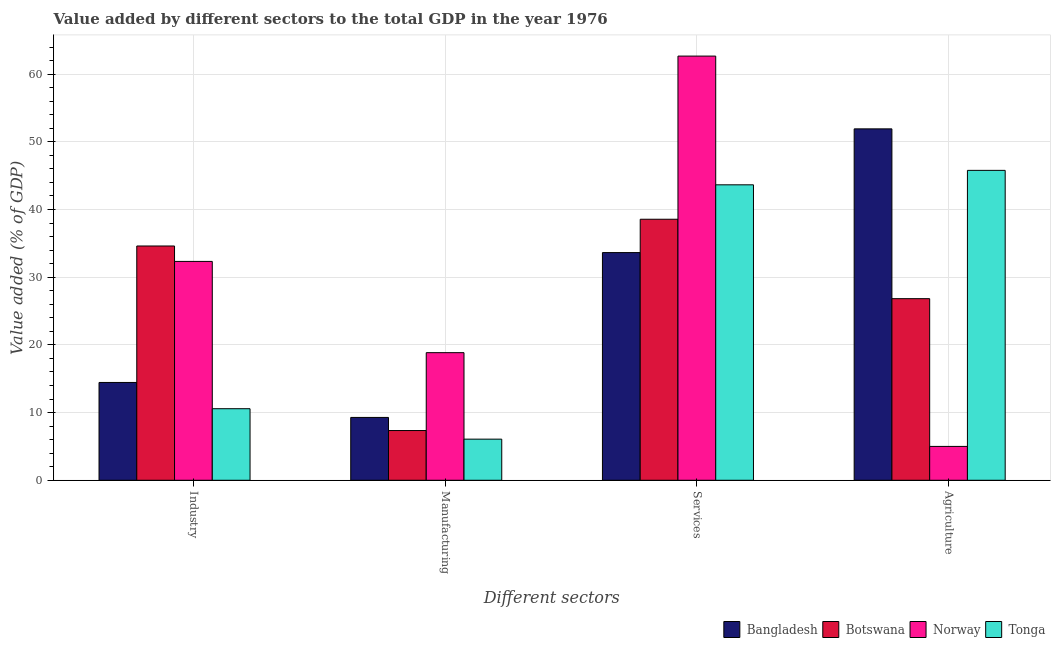How many groups of bars are there?
Your answer should be compact. 4. Are the number of bars per tick equal to the number of legend labels?
Keep it short and to the point. Yes. Are the number of bars on each tick of the X-axis equal?
Offer a very short reply. Yes. How many bars are there on the 3rd tick from the left?
Keep it short and to the point. 4. How many bars are there on the 3rd tick from the right?
Make the answer very short. 4. What is the label of the 3rd group of bars from the left?
Keep it short and to the point. Services. What is the value added by industrial sector in Bangladesh?
Give a very brief answer. 14.45. Across all countries, what is the maximum value added by manufacturing sector?
Offer a terse response. 18.85. Across all countries, what is the minimum value added by manufacturing sector?
Give a very brief answer. 6.07. What is the total value added by manufacturing sector in the graph?
Offer a terse response. 41.56. What is the difference between the value added by services sector in Bangladesh and that in Botswana?
Give a very brief answer. -4.92. What is the difference between the value added by services sector in Bangladesh and the value added by manufacturing sector in Botswana?
Offer a very short reply. 26.29. What is the average value added by services sector per country?
Keep it short and to the point. 44.63. What is the difference between the value added by agricultural sector and value added by industrial sector in Botswana?
Your answer should be compact. -7.78. In how many countries, is the value added by manufacturing sector greater than 6 %?
Offer a terse response. 4. What is the ratio of the value added by industrial sector in Bangladesh to that in Botswana?
Give a very brief answer. 0.42. Is the value added by agricultural sector in Norway less than that in Botswana?
Offer a terse response. Yes. What is the difference between the highest and the second highest value added by services sector?
Offer a terse response. 19.02. What is the difference between the highest and the lowest value added by agricultural sector?
Your response must be concise. 46.91. In how many countries, is the value added by agricultural sector greater than the average value added by agricultural sector taken over all countries?
Provide a succinct answer. 2. What does the 1st bar from the left in Manufacturing represents?
Make the answer very short. Bangladesh. What does the 3rd bar from the right in Agriculture represents?
Offer a terse response. Botswana. Is it the case that in every country, the sum of the value added by industrial sector and value added by manufacturing sector is greater than the value added by services sector?
Ensure brevity in your answer.  No. How many bars are there?
Your answer should be compact. 16. How many countries are there in the graph?
Provide a short and direct response. 4. What is the difference between two consecutive major ticks on the Y-axis?
Your answer should be very brief. 10. Are the values on the major ticks of Y-axis written in scientific E-notation?
Offer a terse response. No. Does the graph contain any zero values?
Offer a very short reply. No. Where does the legend appear in the graph?
Offer a terse response. Bottom right. How many legend labels are there?
Give a very brief answer. 4. What is the title of the graph?
Keep it short and to the point. Value added by different sectors to the total GDP in the year 1976. Does "Netherlands" appear as one of the legend labels in the graph?
Keep it short and to the point. No. What is the label or title of the X-axis?
Offer a very short reply. Different sectors. What is the label or title of the Y-axis?
Offer a very short reply. Value added (% of GDP). What is the Value added (% of GDP) of Bangladesh in Industry?
Your answer should be very brief. 14.45. What is the Value added (% of GDP) in Botswana in Industry?
Offer a terse response. 34.61. What is the Value added (% of GDP) of Norway in Industry?
Make the answer very short. 32.33. What is the Value added (% of GDP) of Tonga in Industry?
Offer a terse response. 10.57. What is the Value added (% of GDP) of Bangladesh in Manufacturing?
Keep it short and to the point. 9.28. What is the Value added (% of GDP) of Botswana in Manufacturing?
Provide a succinct answer. 7.35. What is the Value added (% of GDP) in Norway in Manufacturing?
Offer a terse response. 18.85. What is the Value added (% of GDP) in Tonga in Manufacturing?
Provide a short and direct response. 6.07. What is the Value added (% of GDP) in Bangladesh in Services?
Offer a terse response. 33.64. What is the Value added (% of GDP) of Botswana in Services?
Your answer should be very brief. 38.56. What is the Value added (% of GDP) of Norway in Services?
Give a very brief answer. 62.67. What is the Value added (% of GDP) of Tonga in Services?
Give a very brief answer. 43.65. What is the Value added (% of GDP) of Bangladesh in Agriculture?
Offer a very short reply. 51.91. What is the Value added (% of GDP) of Botswana in Agriculture?
Provide a short and direct response. 26.83. What is the Value added (% of GDP) of Norway in Agriculture?
Provide a short and direct response. 5. What is the Value added (% of GDP) in Tonga in Agriculture?
Give a very brief answer. 45.78. Across all Different sectors, what is the maximum Value added (% of GDP) in Bangladesh?
Your answer should be compact. 51.91. Across all Different sectors, what is the maximum Value added (% of GDP) of Botswana?
Offer a terse response. 38.56. Across all Different sectors, what is the maximum Value added (% of GDP) of Norway?
Your response must be concise. 62.67. Across all Different sectors, what is the maximum Value added (% of GDP) of Tonga?
Provide a short and direct response. 45.78. Across all Different sectors, what is the minimum Value added (% of GDP) of Bangladesh?
Provide a succinct answer. 9.28. Across all Different sectors, what is the minimum Value added (% of GDP) of Botswana?
Offer a very short reply. 7.35. Across all Different sectors, what is the minimum Value added (% of GDP) of Norway?
Keep it short and to the point. 5. Across all Different sectors, what is the minimum Value added (% of GDP) in Tonga?
Make the answer very short. 6.07. What is the total Value added (% of GDP) in Bangladesh in the graph?
Your response must be concise. 109.28. What is the total Value added (% of GDP) in Botswana in the graph?
Offer a very short reply. 107.35. What is the total Value added (% of GDP) in Norway in the graph?
Your answer should be compact. 118.85. What is the total Value added (% of GDP) of Tonga in the graph?
Keep it short and to the point. 106.07. What is the difference between the Value added (% of GDP) of Bangladesh in Industry and that in Manufacturing?
Provide a succinct answer. 5.17. What is the difference between the Value added (% of GDP) in Botswana in Industry and that in Manufacturing?
Your response must be concise. 27.27. What is the difference between the Value added (% of GDP) in Norway in Industry and that in Manufacturing?
Provide a short and direct response. 13.48. What is the difference between the Value added (% of GDP) of Tonga in Industry and that in Manufacturing?
Make the answer very short. 4.5. What is the difference between the Value added (% of GDP) in Bangladesh in Industry and that in Services?
Your answer should be very brief. -19.19. What is the difference between the Value added (% of GDP) in Botswana in Industry and that in Services?
Your answer should be compact. -3.95. What is the difference between the Value added (% of GDP) in Norway in Industry and that in Services?
Offer a very short reply. -30.33. What is the difference between the Value added (% of GDP) of Tonga in Industry and that in Services?
Offer a terse response. -33.08. What is the difference between the Value added (% of GDP) of Bangladesh in Industry and that in Agriculture?
Your response must be concise. -37.47. What is the difference between the Value added (% of GDP) of Botswana in Industry and that in Agriculture?
Provide a succinct answer. 7.78. What is the difference between the Value added (% of GDP) in Norway in Industry and that in Agriculture?
Ensure brevity in your answer.  27.33. What is the difference between the Value added (% of GDP) in Tonga in Industry and that in Agriculture?
Provide a short and direct response. -35.21. What is the difference between the Value added (% of GDP) of Bangladesh in Manufacturing and that in Services?
Your response must be concise. -24.35. What is the difference between the Value added (% of GDP) in Botswana in Manufacturing and that in Services?
Offer a terse response. -31.22. What is the difference between the Value added (% of GDP) in Norway in Manufacturing and that in Services?
Provide a succinct answer. -43.81. What is the difference between the Value added (% of GDP) in Tonga in Manufacturing and that in Services?
Your response must be concise. -37.57. What is the difference between the Value added (% of GDP) of Bangladesh in Manufacturing and that in Agriculture?
Your answer should be very brief. -42.63. What is the difference between the Value added (% of GDP) in Botswana in Manufacturing and that in Agriculture?
Give a very brief answer. -19.48. What is the difference between the Value added (% of GDP) of Norway in Manufacturing and that in Agriculture?
Your answer should be very brief. 13.85. What is the difference between the Value added (% of GDP) in Tonga in Manufacturing and that in Agriculture?
Ensure brevity in your answer.  -39.71. What is the difference between the Value added (% of GDP) of Bangladesh in Services and that in Agriculture?
Make the answer very short. -18.28. What is the difference between the Value added (% of GDP) of Botswana in Services and that in Agriculture?
Ensure brevity in your answer.  11.73. What is the difference between the Value added (% of GDP) in Norway in Services and that in Agriculture?
Provide a short and direct response. 57.66. What is the difference between the Value added (% of GDP) in Tonga in Services and that in Agriculture?
Keep it short and to the point. -2.14. What is the difference between the Value added (% of GDP) of Bangladesh in Industry and the Value added (% of GDP) of Botswana in Manufacturing?
Give a very brief answer. 7.1. What is the difference between the Value added (% of GDP) of Bangladesh in Industry and the Value added (% of GDP) of Norway in Manufacturing?
Your response must be concise. -4.4. What is the difference between the Value added (% of GDP) of Bangladesh in Industry and the Value added (% of GDP) of Tonga in Manufacturing?
Your answer should be compact. 8.37. What is the difference between the Value added (% of GDP) in Botswana in Industry and the Value added (% of GDP) in Norway in Manufacturing?
Your response must be concise. 15.76. What is the difference between the Value added (% of GDP) of Botswana in Industry and the Value added (% of GDP) of Tonga in Manufacturing?
Ensure brevity in your answer.  28.54. What is the difference between the Value added (% of GDP) in Norway in Industry and the Value added (% of GDP) in Tonga in Manufacturing?
Keep it short and to the point. 26.26. What is the difference between the Value added (% of GDP) of Bangladesh in Industry and the Value added (% of GDP) of Botswana in Services?
Your answer should be very brief. -24.11. What is the difference between the Value added (% of GDP) of Bangladesh in Industry and the Value added (% of GDP) of Norway in Services?
Make the answer very short. -48.22. What is the difference between the Value added (% of GDP) of Bangladesh in Industry and the Value added (% of GDP) of Tonga in Services?
Keep it short and to the point. -29.2. What is the difference between the Value added (% of GDP) in Botswana in Industry and the Value added (% of GDP) in Norway in Services?
Keep it short and to the point. -28.05. What is the difference between the Value added (% of GDP) in Botswana in Industry and the Value added (% of GDP) in Tonga in Services?
Your answer should be compact. -9.04. What is the difference between the Value added (% of GDP) in Norway in Industry and the Value added (% of GDP) in Tonga in Services?
Make the answer very short. -11.31. What is the difference between the Value added (% of GDP) in Bangladesh in Industry and the Value added (% of GDP) in Botswana in Agriculture?
Your answer should be compact. -12.38. What is the difference between the Value added (% of GDP) in Bangladesh in Industry and the Value added (% of GDP) in Norway in Agriculture?
Ensure brevity in your answer.  9.45. What is the difference between the Value added (% of GDP) in Bangladesh in Industry and the Value added (% of GDP) in Tonga in Agriculture?
Offer a very short reply. -31.33. What is the difference between the Value added (% of GDP) in Botswana in Industry and the Value added (% of GDP) in Norway in Agriculture?
Make the answer very short. 29.61. What is the difference between the Value added (% of GDP) of Botswana in Industry and the Value added (% of GDP) of Tonga in Agriculture?
Make the answer very short. -11.17. What is the difference between the Value added (% of GDP) of Norway in Industry and the Value added (% of GDP) of Tonga in Agriculture?
Your answer should be very brief. -13.45. What is the difference between the Value added (% of GDP) of Bangladesh in Manufacturing and the Value added (% of GDP) of Botswana in Services?
Offer a terse response. -29.28. What is the difference between the Value added (% of GDP) of Bangladesh in Manufacturing and the Value added (% of GDP) of Norway in Services?
Give a very brief answer. -53.38. What is the difference between the Value added (% of GDP) of Bangladesh in Manufacturing and the Value added (% of GDP) of Tonga in Services?
Offer a terse response. -34.36. What is the difference between the Value added (% of GDP) of Botswana in Manufacturing and the Value added (% of GDP) of Norway in Services?
Your answer should be compact. -55.32. What is the difference between the Value added (% of GDP) in Botswana in Manufacturing and the Value added (% of GDP) in Tonga in Services?
Offer a very short reply. -36.3. What is the difference between the Value added (% of GDP) in Norway in Manufacturing and the Value added (% of GDP) in Tonga in Services?
Your response must be concise. -24.8. What is the difference between the Value added (% of GDP) in Bangladesh in Manufacturing and the Value added (% of GDP) in Botswana in Agriculture?
Your answer should be very brief. -17.54. What is the difference between the Value added (% of GDP) of Bangladesh in Manufacturing and the Value added (% of GDP) of Norway in Agriculture?
Provide a short and direct response. 4.28. What is the difference between the Value added (% of GDP) in Bangladesh in Manufacturing and the Value added (% of GDP) in Tonga in Agriculture?
Your answer should be very brief. -36.5. What is the difference between the Value added (% of GDP) in Botswana in Manufacturing and the Value added (% of GDP) in Norway in Agriculture?
Ensure brevity in your answer.  2.34. What is the difference between the Value added (% of GDP) of Botswana in Manufacturing and the Value added (% of GDP) of Tonga in Agriculture?
Offer a terse response. -38.44. What is the difference between the Value added (% of GDP) of Norway in Manufacturing and the Value added (% of GDP) of Tonga in Agriculture?
Make the answer very short. -26.93. What is the difference between the Value added (% of GDP) in Bangladesh in Services and the Value added (% of GDP) in Botswana in Agriculture?
Your answer should be very brief. 6.81. What is the difference between the Value added (% of GDP) of Bangladesh in Services and the Value added (% of GDP) of Norway in Agriculture?
Provide a short and direct response. 28.63. What is the difference between the Value added (% of GDP) of Bangladesh in Services and the Value added (% of GDP) of Tonga in Agriculture?
Make the answer very short. -12.15. What is the difference between the Value added (% of GDP) in Botswana in Services and the Value added (% of GDP) in Norway in Agriculture?
Make the answer very short. 33.56. What is the difference between the Value added (% of GDP) in Botswana in Services and the Value added (% of GDP) in Tonga in Agriculture?
Make the answer very short. -7.22. What is the difference between the Value added (% of GDP) of Norway in Services and the Value added (% of GDP) of Tonga in Agriculture?
Offer a terse response. 16.88. What is the average Value added (% of GDP) in Bangladesh per Different sectors?
Your answer should be compact. 27.32. What is the average Value added (% of GDP) in Botswana per Different sectors?
Offer a very short reply. 26.84. What is the average Value added (% of GDP) of Norway per Different sectors?
Ensure brevity in your answer.  29.71. What is the average Value added (% of GDP) in Tonga per Different sectors?
Give a very brief answer. 26.52. What is the difference between the Value added (% of GDP) in Bangladesh and Value added (% of GDP) in Botswana in Industry?
Provide a succinct answer. -20.16. What is the difference between the Value added (% of GDP) of Bangladesh and Value added (% of GDP) of Norway in Industry?
Provide a succinct answer. -17.88. What is the difference between the Value added (% of GDP) in Bangladesh and Value added (% of GDP) in Tonga in Industry?
Your answer should be very brief. 3.88. What is the difference between the Value added (% of GDP) in Botswana and Value added (% of GDP) in Norway in Industry?
Your answer should be compact. 2.28. What is the difference between the Value added (% of GDP) in Botswana and Value added (% of GDP) in Tonga in Industry?
Provide a short and direct response. 24.04. What is the difference between the Value added (% of GDP) in Norway and Value added (% of GDP) in Tonga in Industry?
Keep it short and to the point. 21.76. What is the difference between the Value added (% of GDP) of Bangladesh and Value added (% of GDP) of Botswana in Manufacturing?
Give a very brief answer. 1.94. What is the difference between the Value added (% of GDP) of Bangladesh and Value added (% of GDP) of Norway in Manufacturing?
Provide a short and direct response. -9.57. What is the difference between the Value added (% of GDP) in Bangladesh and Value added (% of GDP) in Tonga in Manufacturing?
Provide a succinct answer. 3.21. What is the difference between the Value added (% of GDP) of Botswana and Value added (% of GDP) of Norway in Manufacturing?
Your answer should be compact. -11.51. What is the difference between the Value added (% of GDP) in Botswana and Value added (% of GDP) in Tonga in Manufacturing?
Provide a short and direct response. 1.27. What is the difference between the Value added (% of GDP) in Norway and Value added (% of GDP) in Tonga in Manufacturing?
Make the answer very short. 12.78. What is the difference between the Value added (% of GDP) in Bangladesh and Value added (% of GDP) in Botswana in Services?
Your response must be concise. -4.92. What is the difference between the Value added (% of GDP) of Bangladesh and Value added (% of GDP) of Norway in Services?
Your answer should be very brief. -29.03. What is the difference between the Value added (% of GDP) in Bangladesh and Value added (% of GDP) in Tonga in Services?
Make the answer very short. -10.01. What is the difference between the Value added (% of GDP) in Botswana and Value added (% of GDP) in Norway in Services?
Offer a very short reply. -24.1. What is the difference between the Value added (% of GDP) of Botswana and Value added (% of GDP) of Tonga in Services?
Your answer should be compact. -5.09. What is the difference between the Value added (% of GDP) in Norway and Value added (% of GDP) in Tonga in Services?
Your response must be concise. 19.02. What is the difference between the Value added (% of GDP) of Bangladesh and Value added (% of GDP) of Botswana in Agriculture?
Ensure brevity in your answer.  25.09. What is the difference between the Value added (% of GDP) in Bangladesh and Value added (% of GDP) in Norway in Agriculture?
Provide a short and direct response. 46.91. What is the difference between the Value added (% of GDP) of Bangladesh and Value added (% of GDP) of Tonga in Agriculture?
Your answer should be compact. 6.13. What is the difference between the Value added (% of GDP) of Botswana and Value added (% of GDP) of Norway in Agriculture?
Your answer should be compact. 21.83. What is the difference between the Value added (% of GDP) of Botswana and Value added (% of GDP) of Tonga in Agriculture?
Offer a very short reply. -18.95. What is the difference between the Value added (% of GDP) of Norway and Value added (% of GDP) of Tonga in Agriculture?
Give a very brief answer. -40.78. What is the ratio of the Value added (% of GDP) of Bangladesh in Industry to that in Manufacturing?
Provide a succinct answer. 1.56. What is the ratio of the Value added (% of GDP) of Botswana in Industry to that in Manufacturing?
Offer a very short reply. 4.71. What is the ratio of the Value added (% of GDP) in Norway in Industry to that in Manufacturing?
Offer a terse response. 1.72. What is the ratio of the Value added (% of GDP) in Tonga in Industry to that in Manufacturing?
Your answer should be very brief. 1.74. What is the ratio of the Value added (% of GDP) of Bangladesh in Industry to that in Services?
Ensure brevity in your answer.  0.43. What is the ratio of the Value added (% of GDP) of Botswana in Industry to that in Services?
Provide a succinct answer. 0.9. What is the ratio of the Value added (% of GDP) of Norway in Industry to that in Services?
Your answer should be compact. 0.52. What is the ratio of the Value added (% of GDP) of Tonga in Industry to that in Services?
Provide a short and direct response. 0.24. What is the ratio of the Value added (% of GDP) in Bangladesh in Industry to that in Agriculture?
Your answer should be compact. 0.28. What is the ratio of the Value added (% of GDP) in Botswana in Industry to that in Agriculture?
Your answer should be very brief. 1.29. What is the ratio of the Value added (% of GDP) in Norway in Industry to that in Agriculture?
Your answer should be compact. 6.46. What is the ratio of the Value added (% of GDP) in Tonga in Industry to that in Agriculture?
Your answer should be compact. 0.23. What is the ratio of the Value added (% of GDP) of Bangladesh in Manufacturing to that in Services?
Make the answer very short. 0.28. What is the ratio of the Value added (% of GDP) of Botswana in Manufacturing to that in Services?
Keep it short and to the point. 0.19. What is the ratio of the Value added (% of GDP) of Norway in Manufacturing to that in Services?
Your answer should be very brief. 0.3. What is the ratio of the Value added (% of GDP) of Tonga in Manufacturing to that in Services?
Give a very brief answer. 0.14. What is the ratio of the Value added (% of GDP) in Bangladesh in Manufacturing to that in Agriculture?
Your answer should be very brief. 0.18. What is the ratio of the Value added (% of GDP) in Botswana in Manufacturing to that in Agriculture?
Provide a succinct answer. 0.27. What is the ratio of the Value added (% of GDP) in Norway in Manufacturing to that in Agriculture?
Your answer should be very brief. 3.77. What is the ratio of the Value added (% of GDP) of Tonga in Manufacturing to that in Agriculture?
Keep it short and to the point. 0.13. What is the ratio of the Value added (% of GDP) in Bangladesh in Services to that in Agriculture?
Offer a terse response. 0.65. What is the ratio of the Value added (% of GDP) of Botswana in Services to that in Agriculture?
Make the answer very short. 1.44. What is the ratio of the Value added (% of GDP) in Norway in Services to that in Agriculture?
Offer a terse response. 12.53. What is the ratio of the Value added (% of GDP) of Tonga in Services to that in Agriculture?
Give a very brief answer. 0.95. What is the difference between the highest and the second highest Value added (% of GDP) in Bangladesh?
Your answer should be very brief. 18.28. What is the difference between the highest and the second highest Value added (% of GDP) in Botswana?
Your response must be concise. 3.95. What is the difference between the highest and the second highest Value added (% of GDP) of Norway?
Your answer should be compact. 30.33. What is the difference between the highest and the second highest Value added (% of GDP) in Tonga?
Offer a terse response. 2.14. What is the difference between the highest and the lowest Value added (% of GDP) in Bangladesh?
Offer a terse response. 42.63. What is the difference between the highest and the lowest Value added (% of GDP) in Botswana?
Give a very brief answer. 31.22. What is the difference between the highest and the lowest Value added (% of GDP) of Norway?
Your response must be concise. 57.66. What is the difference between the highest and the lowest Value added (% of GDP) in Tonga?
Offer a terse response. 39.71. 